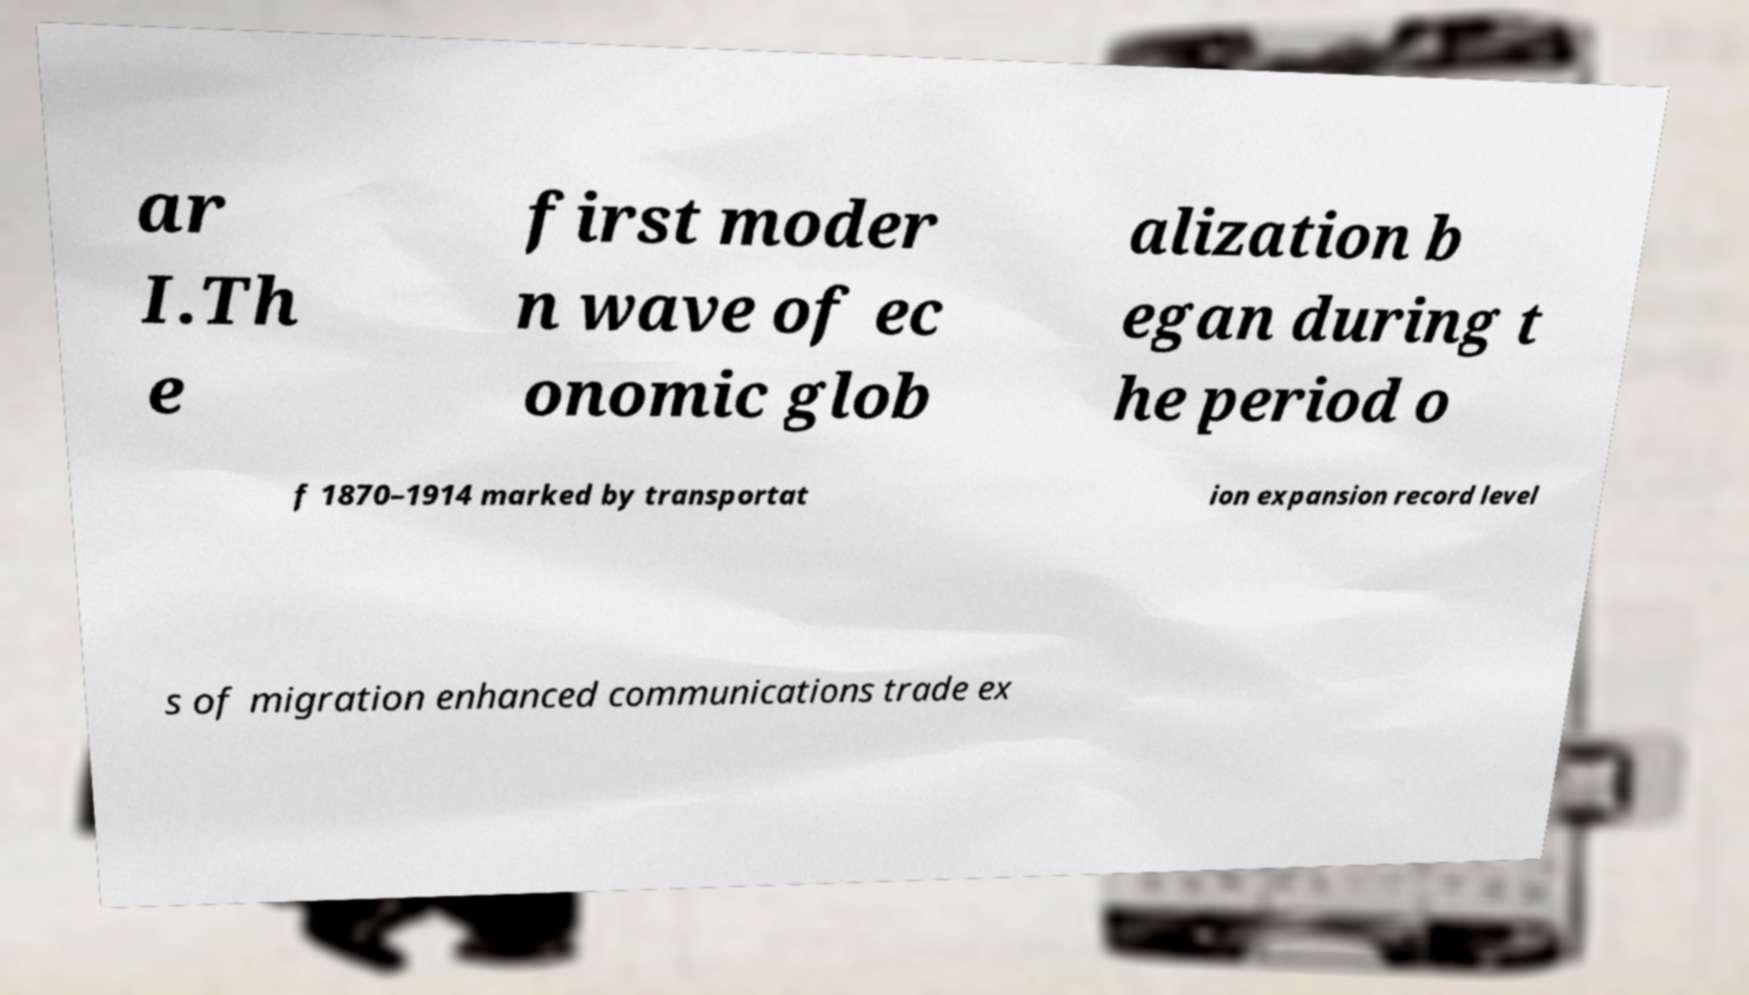Please read and relay the text visible in this image. What does it say? ar I.Th e first moder n wave of ec onomic glob alization b egan during t he period o f 1870–1914 marked by transportat ion expansion record level s of migration enhanced communications trade ex 